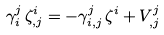<formula> <loc_0><loc_0><loc_500><loc_500>\gamma _ { i } ^ { j } \, \zeta _ { , j } ^ { i } = - \gamma _ { i , j } ^ { j } \, \zeta ^ { i } + V _ { , j } ^ { j }</formula> 